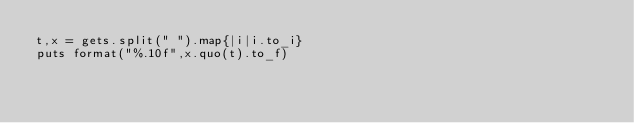<code> <loc_0><loc_0><loc_500><loc_500><_Ruby_>t,x = gets.split(" ").map{|i|i.to_i}
puts format("%.10f",x.quo(t).to_f)</code> 